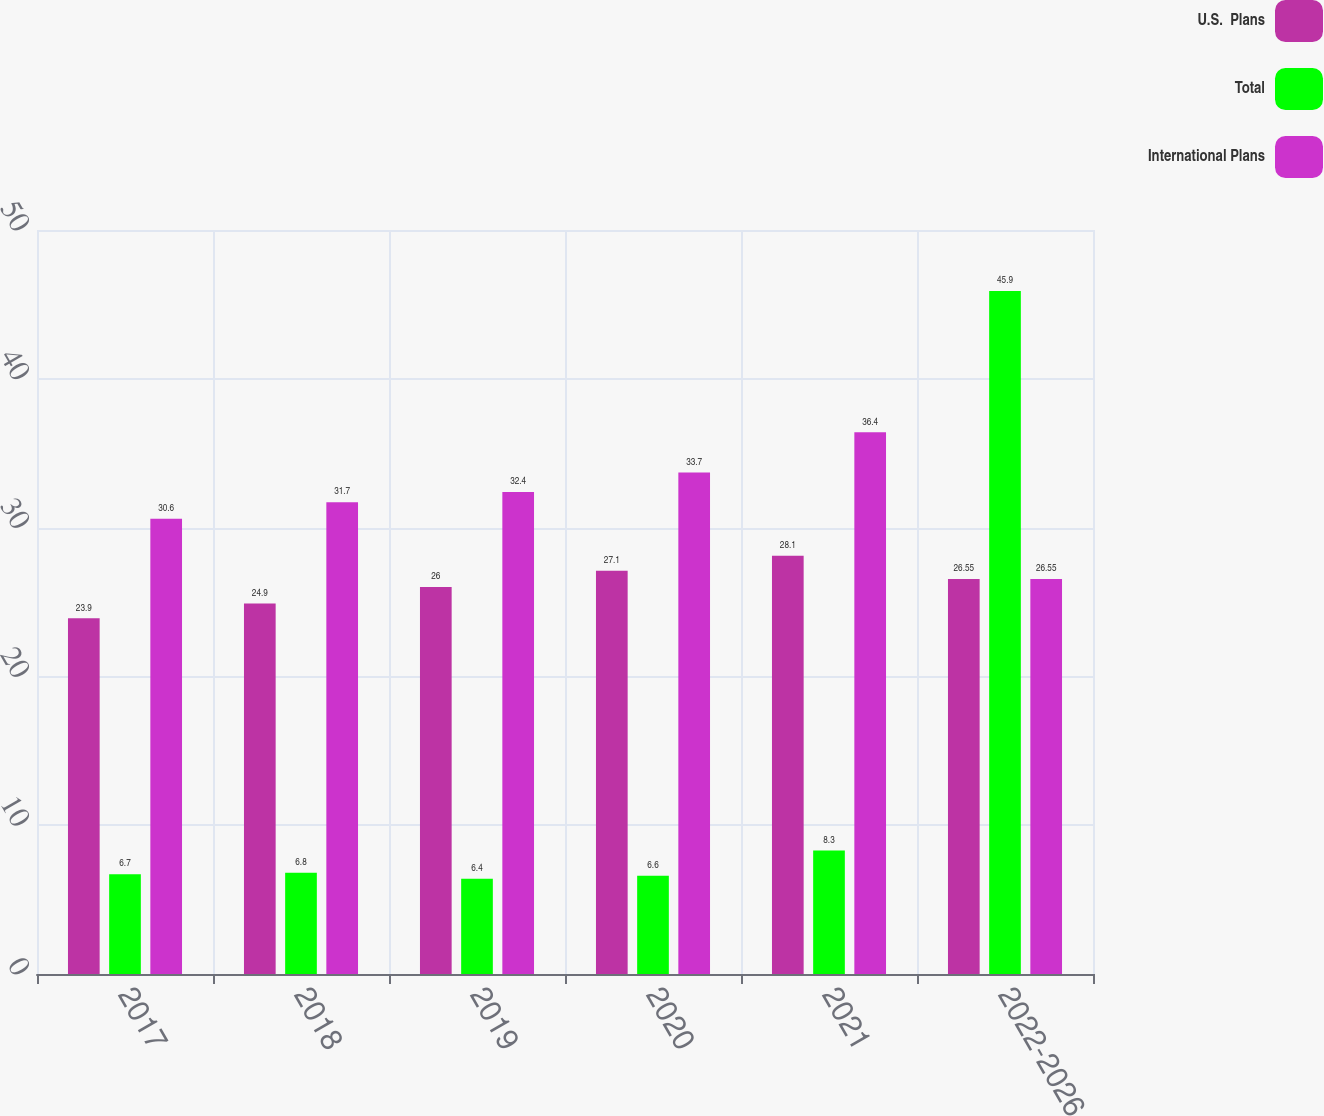<chart> <loc_0><loc_0><loc_500><loc_500><stacked_bar_chart><ecel><fcel>2017<fcel>2018<fcel>2019<fcel>2020<fcel>2021<fcel>2022-2026<nl><fcel>U.S.  Plans<fcel>23.9<fcel>24.9<fcel>26<fcel>27.1<fcel>28.1<fcel>26.55<nl><fcel>Total<fcel>6.7<fcel>6.8<fcel>6.4<fcel>6.6<fcel>8.3<fcel>45.9<nl><fcel>International Plans<fcel>30.6<fcel>31.7<fcel>32.4<fcel>33.7<fcel>36.4<fcel>26.55<nl></chart> 